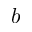Convert formula to latex. <formula><loc_0><loc_0><loc_500><loc_500>b</formula> 